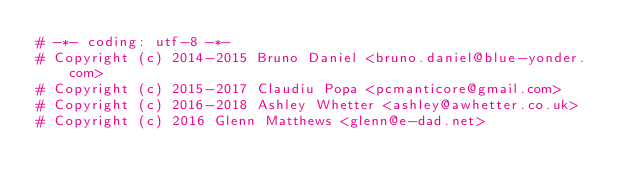<code> <loc_0><loc_0><loc_500><loc_500><_Python_># -*- coding: utf-8 -*-
# Copyright (c) 2014-2015 Bruno Daniel <bruno.daniel@blue-yonder.com>
# Copyright (c) 2015-2017 Claudiu Popa <pcmanticore@gmail.com>
# Copyright (c) 2016-2018 Ashley Whetter <ashley@awhetter.co.uk>
# Copyright (c) 2016 Glenn Matthews <glenn@e-dad.net></code> 